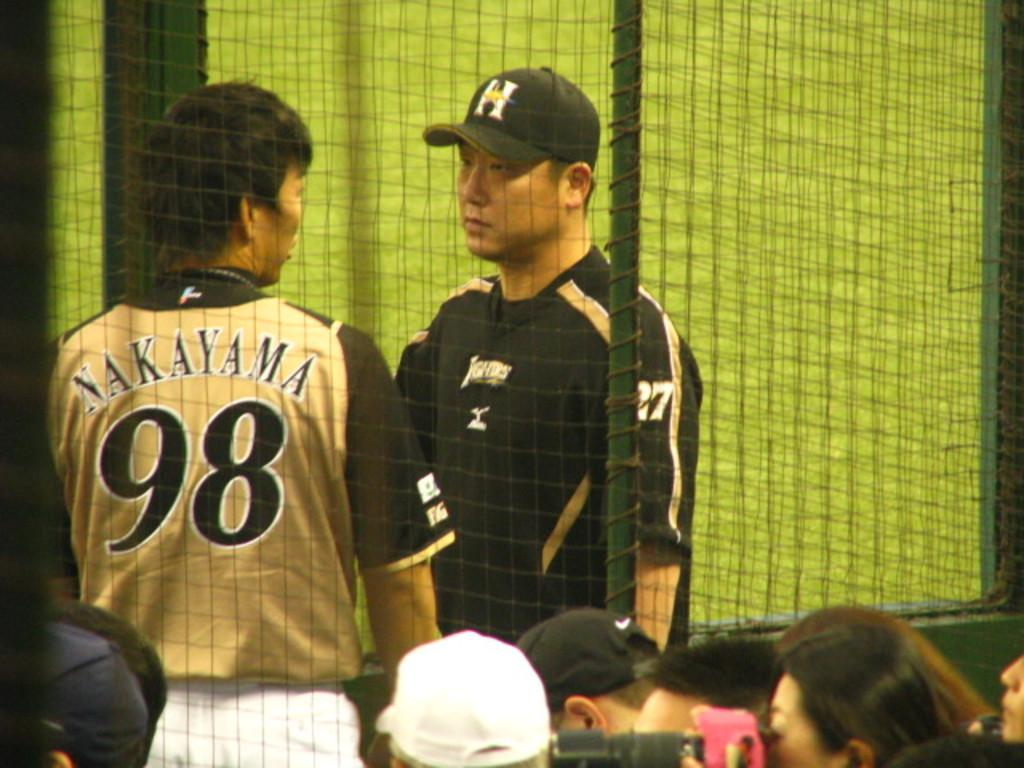<image>
Share a concise interpretation of the image provided. A man is wearing a jersey with the number 98 on the back. 